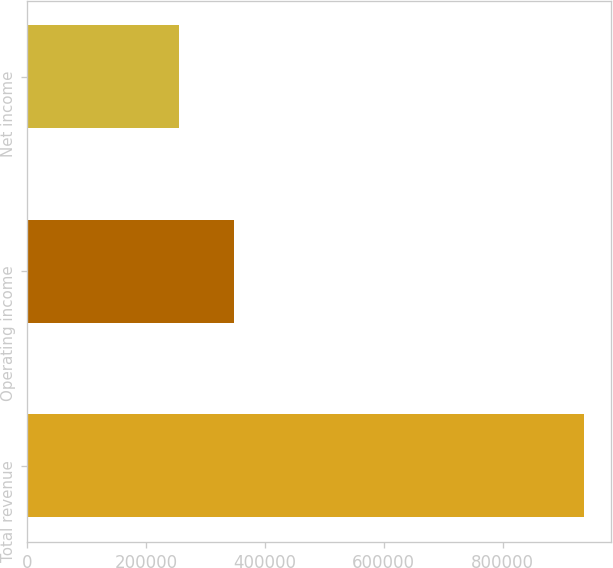<chart> <loc_0><loc_0><loc_500><loc_500><bar_chart><fcel>Total revenue<fcel>Operating income<fcel>Net income<nl><fcel>936021<fcel>347450<fcel>254690<nl></chart> 